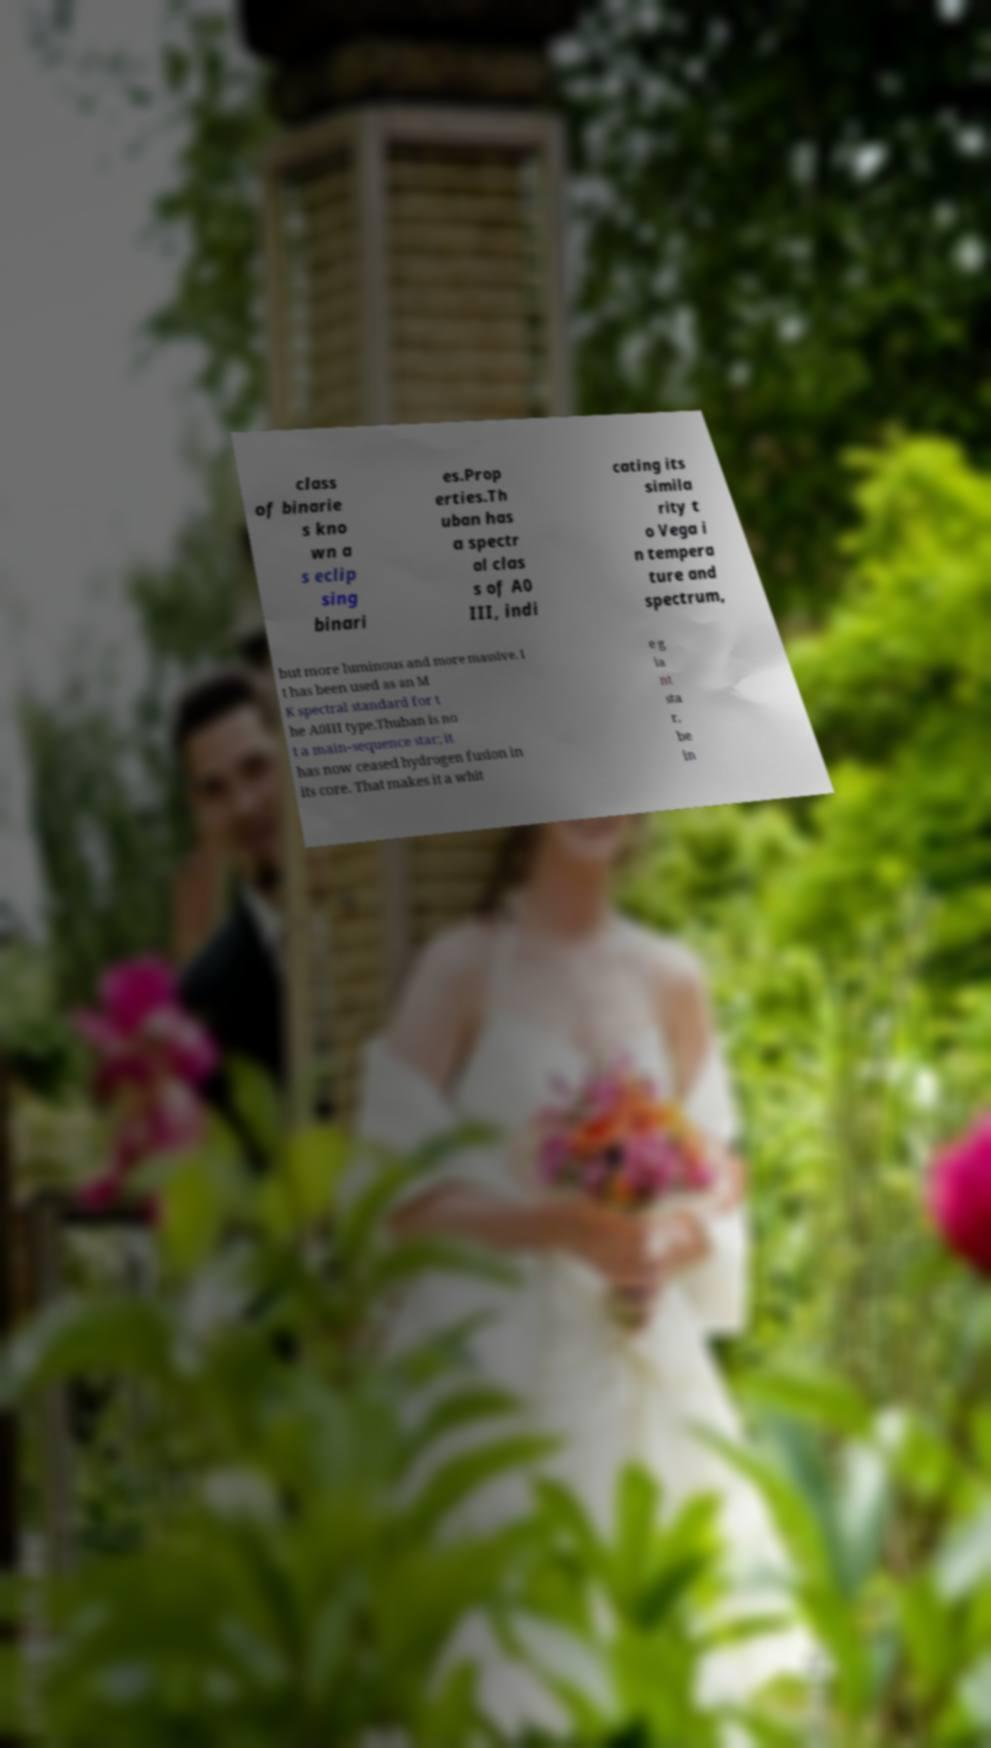Can you accurately transcribe the text from the provided image for me? class of binarie s kno wn a s eclip sing binari es.Prop erties.Th uban has a spectr al clas s of A0 III, indi cating its simila rity t o Vega i n tempera ture and spectrum, but more luminous and more massive. I t has been used as an M K spectral standard for t he A0III type.Thuban is no t a main-sequence star; it has now ceased hydrogen fusion in its core. That makes it a whit e g ia nt sta r, be in 